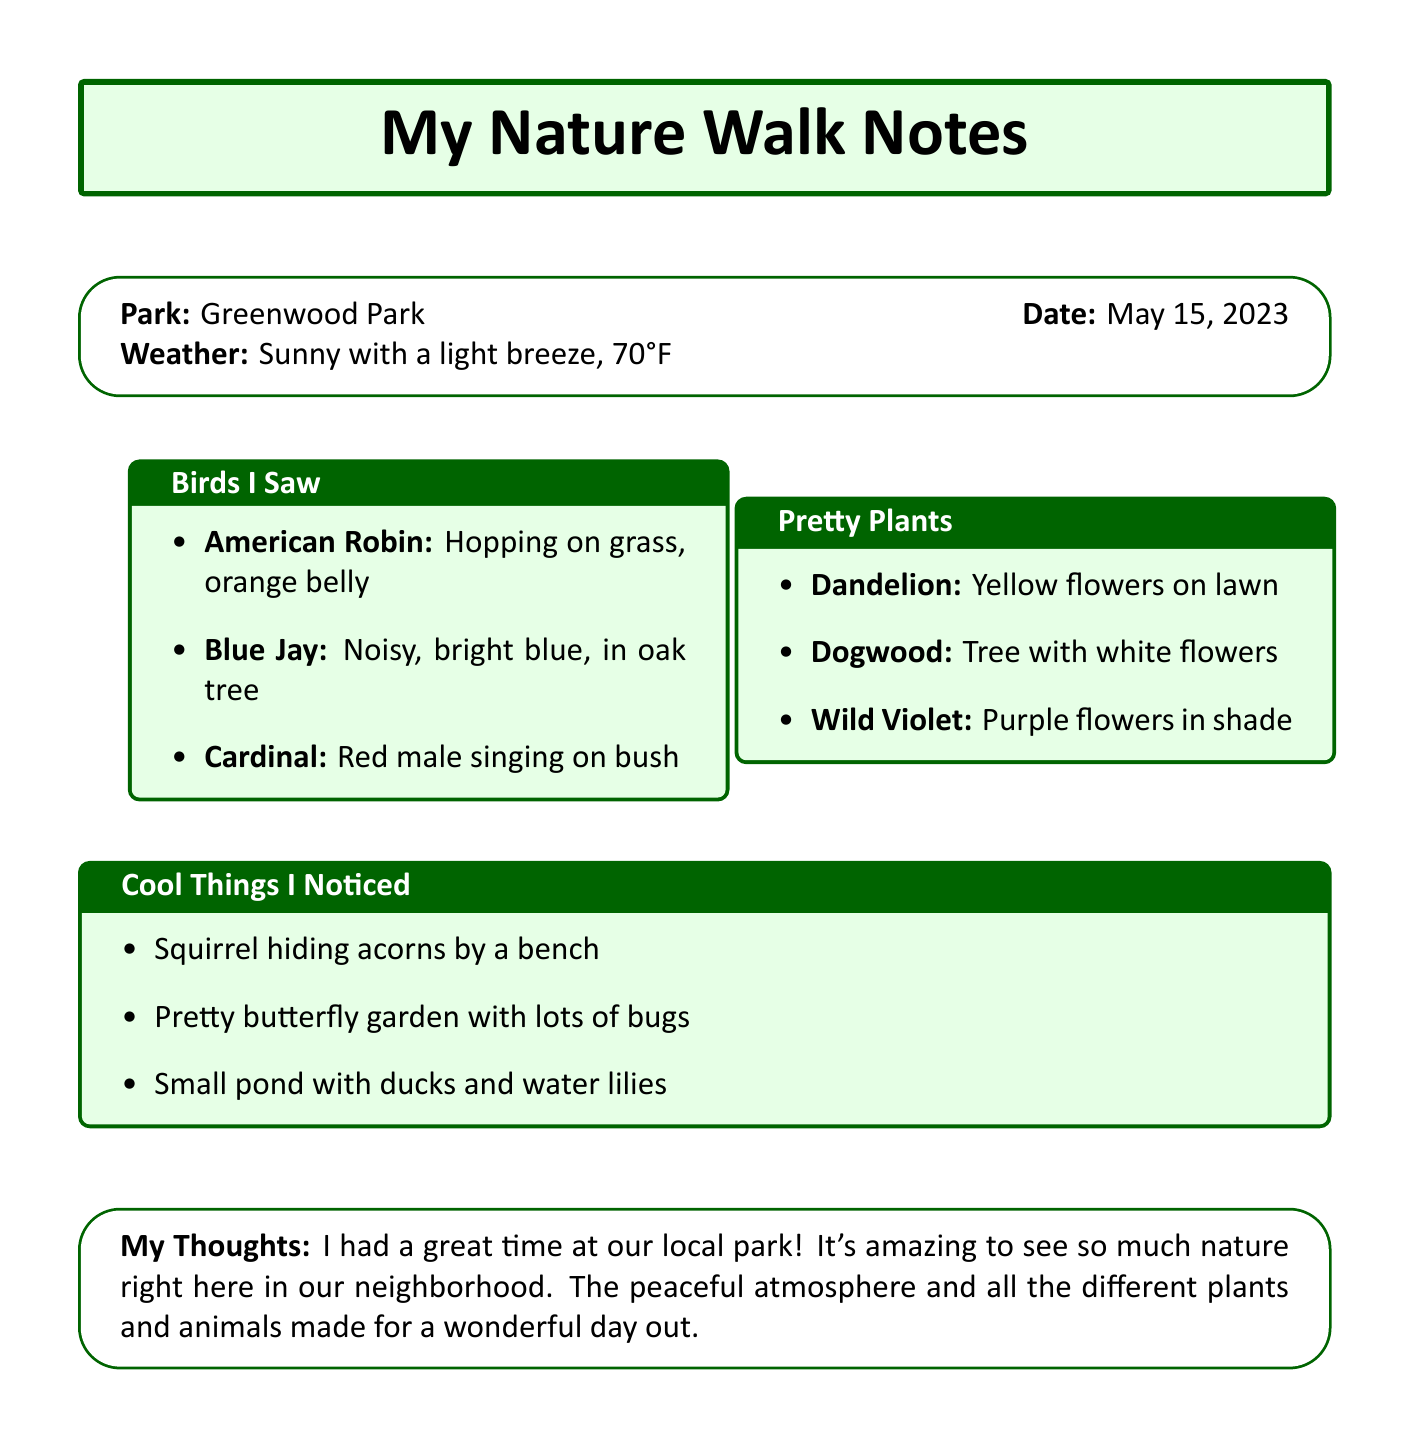what is the name of the park? The name of the park is provided at the beginning of the document.
Answer: Greenwood Park when did the nature walk take place? The date of the nature walk is clearly stated in the document.
Answer: May 15, 2023 what type of weather was it during the walk? The weather details are included in the document under the weather section.
Answer: Sunny with a light breeze, 70°F how many bird species were spotted? The number of bird sightings can be counted from the bird sightings section.
Answer: 3 which bird had a bright orange belly? The description of the American Robin specifies its bright orange belly.
Answer: American Robin what color are the flowers of the Dogwood? The description of the Dogwood clearly mentions the color of its flowers.
Answer: White what animal was observed burying acorns? The interesting observation mentions a specific animal that was seen burying acorns.
Answer: Squirrel what was noted about the butterfly garden? The document describes an interesting aspect of the butterfly garden.
Answer: Colorful flowers attracting various insects how did the observer feel about the nature walk? The personal reflection at the end provides insights into the observer's feelings.
Answer: Enjoyed the peaceful atmosphere and variety of nature 